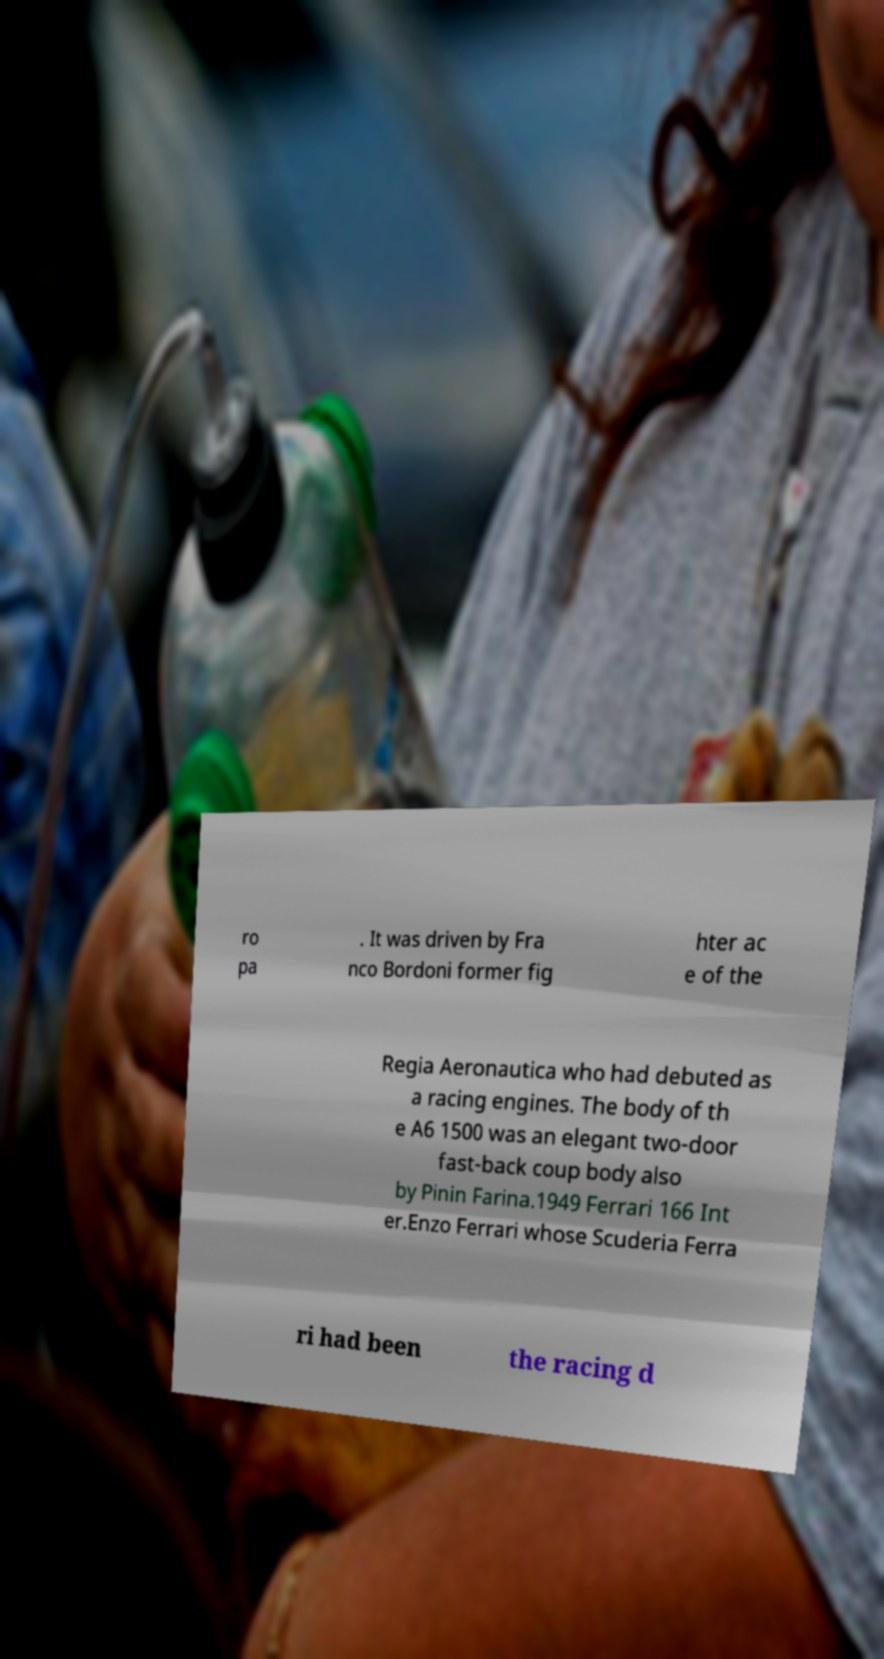Could you extract and type out the text from this image? ro pa . It was driven by Fra nco Bordoni former fig hter ac e of the Regia Aeronautica who had debuted as a racing engines. The body of th e A6 1500 was an elegant two-door fast-back coup body also by Pinin Farina.1949 Ferrari 166 Int er.Enzo Ferrari whose Scuderia Ferra ri had been the racing d 